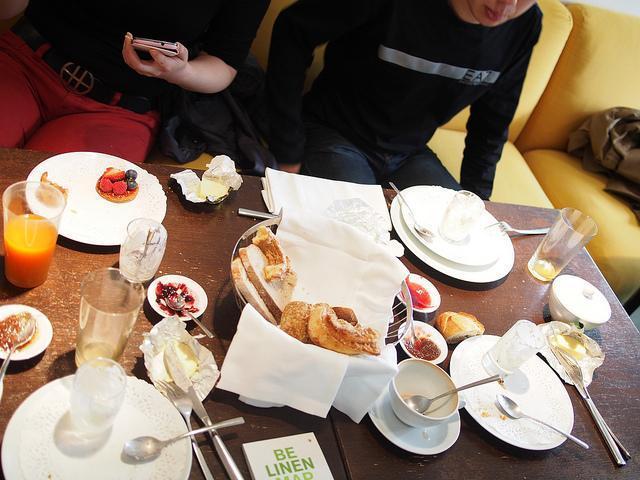How many empty plates in the picture?
Give a very brief answer. 4. How many place settings?
Give a very brief answer. 4. How many cups are in the photo?
Give a very brief answer. 6. How many couches can you see?
Give a very brief answer. 1. How many bowls are there?
Give a very brief answer. 3. How many people can be seen?
Give a very brief answer. 2. How many cakes are present?
Give a very brief answer. 0. 